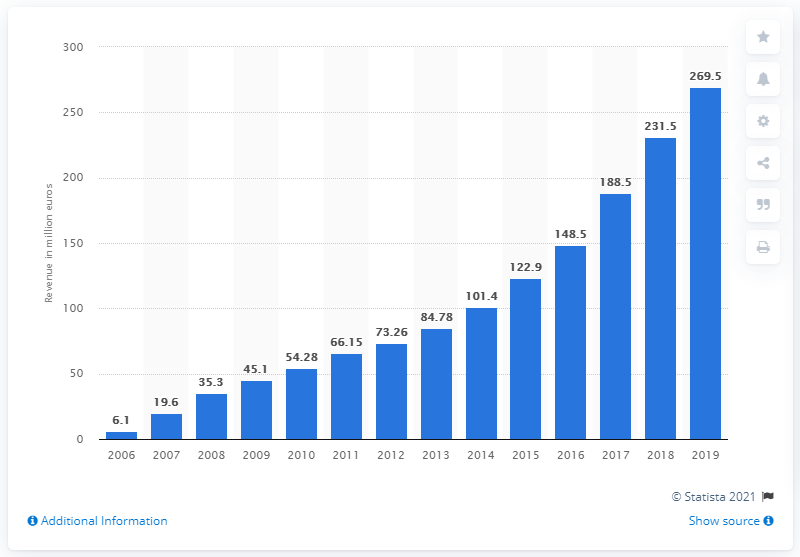Specify some key components in this picture. Xing AG's revenue in the previous year was approximately 231.5. In 2019, Xing AG generated a revenue of 269.5... 